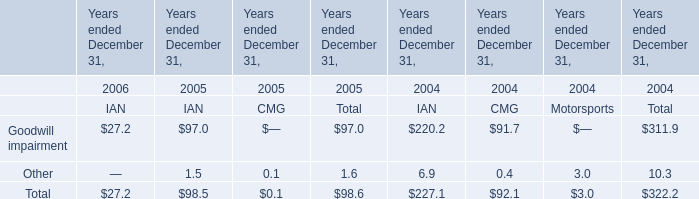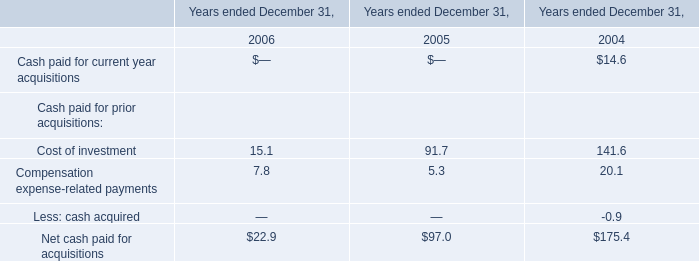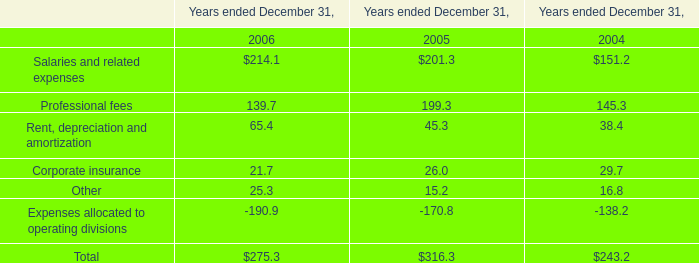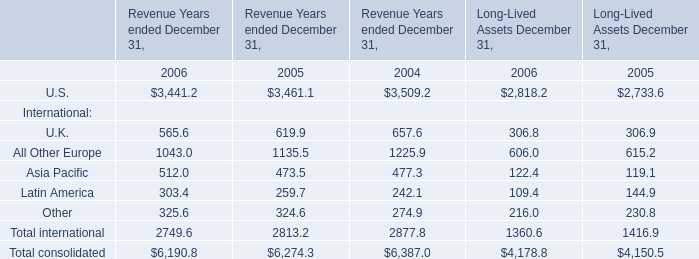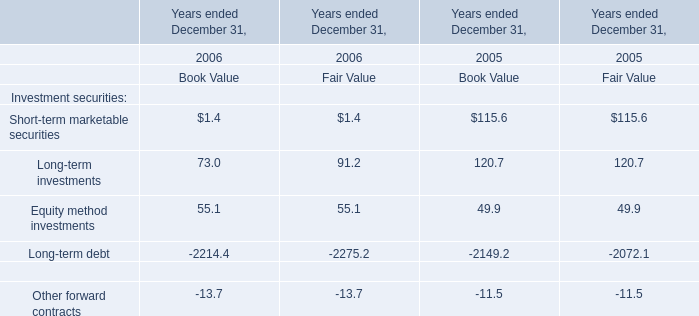What's the current increasing rate of U.K. for Revenue Years ended December 31? 
Computations: ((565.6 - 619.9) / 619.9)
Answer: -0.08759. 